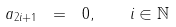Convert formula to latex. <formula><loc_0><loc_0><loc_500><loc_500>a _ { 2 i + 1 } \ = \ 0 , \quad i \in \mathbb { N }</formula> 